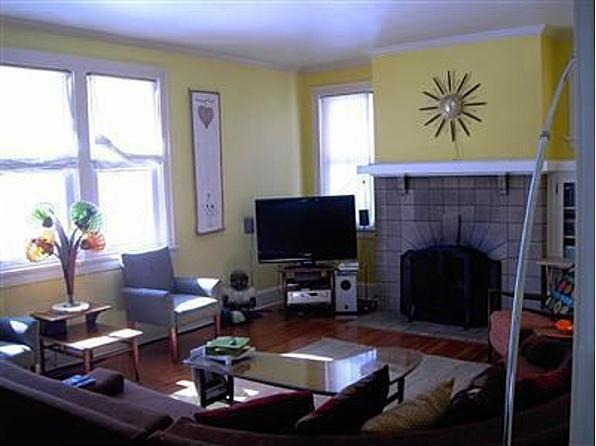How many chairs are there?
Give a very brief answer. 2. How many couches are there?
Give a very brief answer. 2. How many airplanes are in the picture?
Give a very brief answer. 0. 